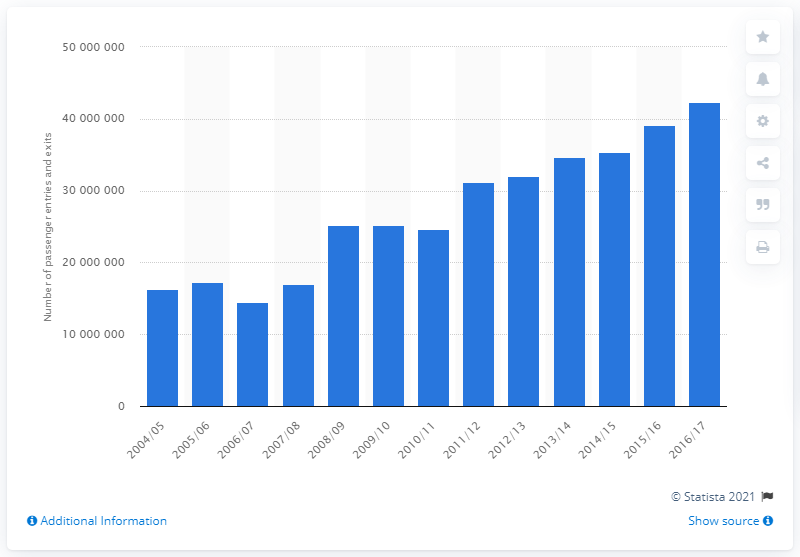Specify some key components in this picture. In 2012/13, a total of 32090346 passengers passed through Birmingham New Street Station. In 2016/17, a total of 4,236,6776 passengers passed through Birmingham New Street Station. 